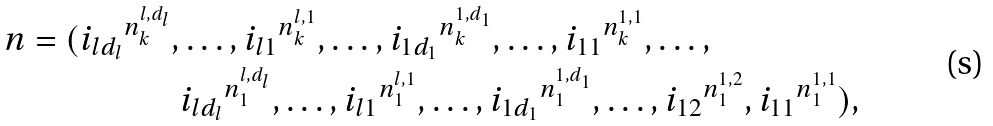<formula> <loc_0><loc_0><loc_500><loc_500>\ n = ( { i _ { l d _ { l } } } ^ { n _ { k } ^ { l , d _ { l } } } , & \dots , { i _ { l 1 } } ^ { n _ { k } ^ { l , 1 } } , \dots , { i _ { 1 d _ { 1 } } } ^ { n _ { k } ^ { 1 , d _ { 1 } } } , \dots , { i _ { 1 1 } } ^ { n _ { k } ^ { 1 , 1 } } , \dots , \\ & { i _ { l d _ { l } } } ^ { n _ { 1 } ^ { l , d _ { l } } } , \dots , { i _ { l 1 } } ^ { n _ { 1 } ^ { l , 1 } } , \dots , { i _ { 1 d _ { 1 } } } ^ { n _ { 1 } ^ { 1 , d _ { 1 } } } , \dots , { i _ { 1 2 } } ^ { n _ { 1 } ^ { 1 , 2 } } , { i _ { 1 1 } } ^ { n _ { 1 } ^ { 1 , 1 } } ) ,</formula> 